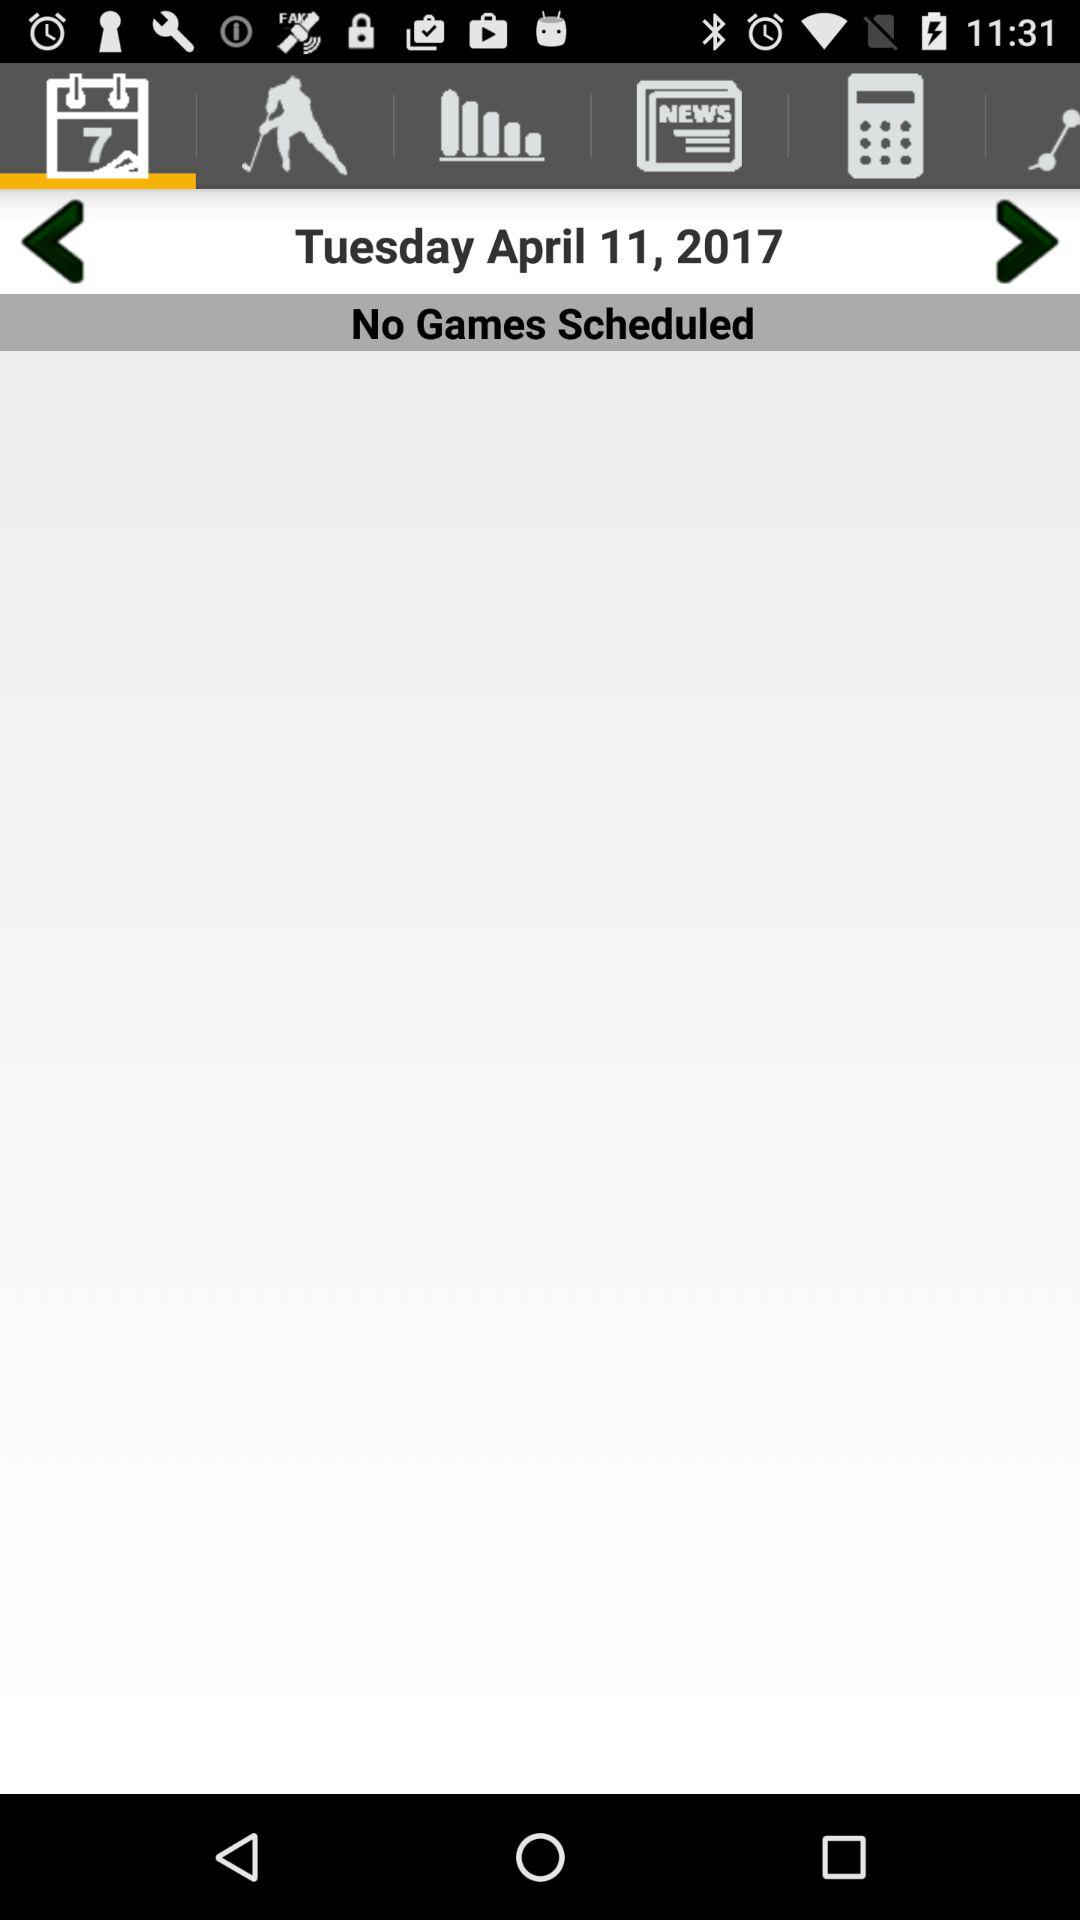What is the date? The date is Tuesday, April 11, 2017. 